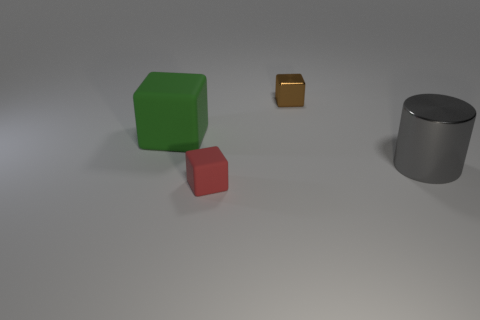Is the number of big gray metal cylinders that are in front of the small red block the same as the number of small metallic cubes that are behind the large metallic cylinder?
Make the answer very short. No. What is the material of the small cube that is in front of the green block?
Make the answer very short. Rubber. Is the number of large metal objects less than the number of purple balls?
Your response must be concise. No. What shape is the object that is both on the left side of the small brown shiny block and on the right side of the big green matte thing?
Make the answer very short. Cube. How many tiny brown spheres are there?
Give a very brief answer. 0. What material is the tiny object in front of the metallic object on the right side of the tiny block that is behind the gray shiny object?
Ensure brevity in your answer.  Rubber. How many large gray things are in front of the tiny object that is in front of the green object?
Offer a very short reply. 0. There is a small matte object that is the same shape as the large rubber object; what color is it?
Provide a short and direct response. Red. Are the green thing and the red block made of the same material?
Your answer should be compact. Yes. What number of blocks are either large purple shiny things or big green matte things?
Make the answer very short. 1. 